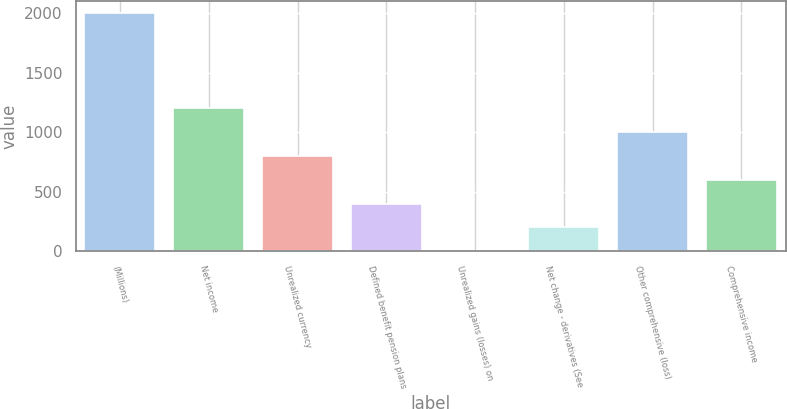Convert chart to OTSL. <chart><loc_0><loc_0><loc_500><loc_500><bar_chart><fcel>(Millions)<fcel>Net income<fcel>Unrealized currency<fcel>Defined benefit pension plans<fcel>Unrealized gains (losses) on<fcel>Net change - derivatives (See<fcel>Other comprehensive (loss)<fcel>Comprehensive income<nl><fcel>2005<fcel>1203.4<fcel>802.6<fcel>401.8<fcel>1<fcel>201.4<fcel>1003<fcel>602.2<nl></chart> 